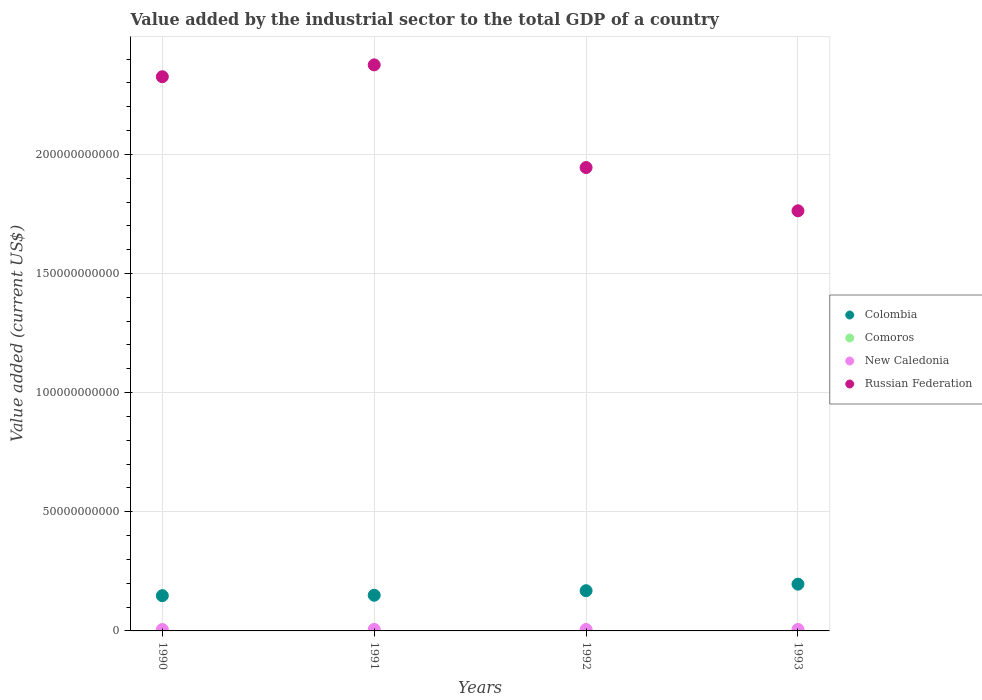What is the value added by the industrial sector to the total GDP in Colombia in 1990?
Make the answer very short. 1.48e+1. Across all years, what is the maximum value added by the industrial sector to the total GDP in New Caledonia?
Your answer should be very brief. 6.39e+08. Across all years, what is the minimum value added by the industrial sector to the total GDP in Russian Federation?
Keep it short and to the point. 1.76e+11. In which year was the value added by the industrial sector to the total GDP in Colombia minimum?
Provide a short and direct response. 1990. What is the total value added by the industrial sector to the total GDP in Russian Federation in the graph?
Your answer should be very brief. 8.41e+11. What is the difference between the value added by the industrial sector to the total GDP in Russian Federation in 1991 and that in 1992?
Your answer should be very brief. 4.31e+1. What is the difference between the value added by the industrial sector to the total GDP in Russian Federation in 1993 and the value added by the industrial sector to the total GDP in New Caledonia in 1990?
Your answer should be compact. 1.76e+11. What is the average value added by the industrial sector to the total GDP in Russian Federation per year?
Offer a very short reply. 2.10e+11. In the year 1991, what is the difference between the value added by the industrial sector to the total GDP in Comoros and value added by the industrial sector to the total GDP in New Caledonia?
Ensure brevity in your answer.  -6.16e+08. What is the ratio of the value added by the industrial sector to the total GDP in Russian Federation in 1990 to that in 1991?
Keep it short and to the point. 0.98. Is the difference between the value added by the industrial sector to the total GDP in Comoros in 1990 and 1992 greater than the difference between the value added by the industrial sector to the total GDP in New Caledonia in 1990 and 1992?
Provide a succinct answer. Yes. What is the difference between the highest and the second highest value added by the industrial sector to the total GDP in New Caledonia?
Ensure brevity in your answer.  1.64e+07. What is the difference between the highest and the lowest value added by the industrial sector to the total GDP in Colombia?
Offer a terse response. 4.83e+09. Is the sum of the value added by the industrial sector to the total GDP in Comoros in 1990 and 1991 greater than the maximum value added by the industrial sector to the total GDP in New Caledonia across all years?
Your response must be concise. No. Is it the case that in every year, the sum of the value added by the industrial sector to the total GDP in Colombia and value added by the industrial sector to the total GDP in New Caledonia  is greater than the sum of value added by the industrial sector to the total GDP in Comoros and value added by the industrial sector to the total GDP in Russian Federation?
Make the answer very short. Yes. Does the value added by the industrial sector to the total GDP in Comoros monotonically increase over the years?
Your answer should be compact. Yes. Is the value added by the industrial sector to the total GDP in Russian Federation strictly less than the value added by the industrial sector to the total GDP in Colombia over the years?
Keep it short and to the point. No. How many years are there in the graph?
Your response must be concise. 4. Does the graph contain any zero values?
Offer a very short reply. No. What is the title of the graph?
Your answer should be compact. Value added by the industrial sector to the total GDP of a country. What is the label or title of the Y-axis?
Offer a very short reply. Value added (current US$). What is the Value added (current US$) of Colombia in 1990?
Your response must be concise. 1.48e+1. What is the Value added (current US$) in Comoros in 1990?
Your answer should be very brief. 2.07e+07. What is the Value added (current US$) of New Caledonia in 1990?
Make the answer very short. 5.90e+08. What is the Value added (current US$) of Russian Federation in 1990?
Offer a very short reply. 2.33e+11. What is the Value added (current US$) of Colombia in 1991?
Ensure brevity in your answer.  1.50e+1. What is the Value added (current US$) in Comoros in 1991?
Your answer should be very brief. 2.31e+07. What is the Value added (current US$) of New Caledonia in 1991?
Offer a very short reply. 6.39e+08. What is the Value added (current US$) of Russian Federation in 1991?
Ensure brevity in your answer.  2.38e+11. What is the Value added (current US$) in Colombia in 1992?
Keep it short and to the point. 1.69e+1. What is the Value added (current US$) in Comoros in 1992?
Your answer should be very brief. 3.05e+07. What is the Value added (current US$) of New Caledonia in 1992?
Offer a terse response. 6.03e+08. What is the Value added (current US$) of Russian Federation in 1992?
Keep it short and to the point. 1.94e+11. What is the Value added (current US$) of Colombia in 1993?
Provide a short and direct response. 1.96e+1. What is the Value added (current US$) of Comoros in 1993?
Offer a terse response. 3.15e+07. What is the Value added (current US$) of New Caledonia in 1993?
Your answer should be compact. 6.23e+08. What is the Value added (current US$) in Russian Federation in 1993?
Your answer should be compact. 1.76e+11. Across all years, what is the maximum Value added (current US$) in Colombia?
Keep it short and to the point. 1.96e+1. Across all years, what is the maximum Value added (current US$) in Comoros?
Give a very brief answer. 3.15e+07. Across all years, what is the maximum Value added (current US$) in New Caledonia?
Offer a very short reply. 6.39e+08. Across all years, what is the maximum Value added (current US$) in Russian Federation?
Make the answer very short. 2.38e+11. Across all years, what is the minimum Value added (current US$) of Colombia?
Make the answer very short. 1.48e+1. Across all years, what is the minimum Value added (current US$) in Comoros?
Ensure brevity in your answer.  2.07e+07. Across all years, what is the minimum Value added (current US$) of New Caledonia?
Give a very brief answer. 5.90e+08. Across all years, what is the minimum Value added (current US$) in Russian Federation?
Keep it short and to the point. 1.76e+11. What is the total Value added (current US$) in Colombia in the graph?
Your answer should be compact. 6.63e+1. What is the total Value added (current US$) in Comoros in the graph?
Provide a succinct answer. 1.06e+08. What is the total Value added (current US$) of New Caledonia in the graph?
Provide a short and direct response. 2.46e+09. What is the total Value added (current US$) in Russian Federation in the graph?
Keep it short and to the point. 8.41e+11. What is the difference between the Value added (current US$) of Colombia in 1990 and that in 1991?
Provide a short and direct response. -1.76e+08. What is the difference between the Value added (current US$) in Comoros in 1990 and that in 1991?
Your response must be concise. -2.46e+06. What is the difference between the Value added (current US$) of New Caledonia in 1990 and that in 1991?
Provide a short and direct response. -4.98e+07. What is the difference between the Value added (current US$) of Russian Federation in 1990 and that in 1991?
Keep it short and to the point. -4.98e+09. What is the difference between the Value added (current US$) in Colombia in 1990 and that in 1992?
Make the answer very short. -2.08e+09. What is the difference between the Value added (current US$) in Comoros in 1990 and that in 1992?
Your answer should be compact. -9.79e+06. What is the difference between the Value added (current US$) in New Caledonia in 1990 and that in 1992?
Offer a terse response. -1.39e+07. What is the difference between the Value added (current US$) in Russian Federation in 1990 and that in 1992?
Give a very brief answer. 3.81e+1. What is the difference between the Value added (current US$) of Colombia in 1990 and that in 1993?
Your answer should be compact. -4.83e+09. What is the difference between the Value added (current US$) of Comoros in 1990 and that in 1993?
Your response must be concise. -1.09e+07. What is the difference between the Value added (current US$) in New Caledonia in 1990 and that in 1993?
Provide a succinct answer. -3.34e+07. What is the difference between the Value added (current US$) of Russian Federation in 1990 and that in 1993?
Provide a short and direct response. 5.63e+1. What is the difference between the Value added (current US$) in Colombia in 1991 and that in 1992?
Provide a succinct answer. -1.91e+09. What is the difference between the Value added (current US$) of Comoros in 1991 and that in 1992?
Give a very brief answer. -7.34e+06. What is the difference between the Value added (current US$) in New Caledonia in 1991 and that in 1992?
Your response must be concise. 3.59e+07. What is the difference between the Value added (current US$) of Russian Federation in 1991 and that in 1992?
Make the answer very short. 4.31e+1. What is the difference between the Value added (current US$) in Colombia in 1991 and that in 1993?
Give a very brief answer. -4.66e+09. What is the difference between the Value added (current US$) in Comoros in 1991 and that in 1993?
Keep it short and to the point. -8.40e+06. What is the difference between the Value added (current US$) of New Caledonia in 1991 and that in 1993?
Keep it short and to the point. 1.64e+07. What is the difference between the Value added (current US$) of Russian Federation in 1991 and that in 1993?
Your answer should be compact. 6.12e+1. What is the difference between the Value added (current US$) of Colombia in 1992 and that in 1993?
Keep it short and to the point. -2.75e+09. What is the difference between the Value added (current US$) in Comoros in 1992 and that in 1993?
Give a very brief answer. -1.06e+06. What is the difference between the Value added (current US$) in New Caledonia in 1992 and that in 1993?
Ensure brevity in your answer.  -1.95e+07. What is the difference between the Value added (current US$) in Russian Federation in 1992 and that in 1993?
Offer a very short reply. 1.82e+1. What is the difference between the Value added (current US$) in Colombia in 1990 and the Value added (current US$) in Comoros in 1991?
Provide a succinct answer. 1.48e+1. What is the difference between the Value added (current US$) of Colombia in 1990 and the Value added (current US$) of New Caledonia in 1991?
Provide a succinct answer. 1.42e+1. What is the difference between the Value added (current US$) of Colombia in 1990 and the Value added (current US$) of Russian Federation in 1991?
Offer a very short reply. -2.23e+11. What is the difference between the Value added (current US$) of Comoros in 1990 and the Value added (current US$) of New Caledonia in 1991?
Ensure brevity in your answer.  -6.19e+08. What is the difference between the Value added (current US$) in Comoros in 1990 and the Value added (current US$) in Russian Federation in 1991?
Ensure brevity in your answer.  -2.38e+11. What is the difference between the Value added (current US$) of New Caledonia in 1990 and the Value added (current US$) of Russian Federation in 1991?
Your answer should be compact. -2.37e+11. What is the difference between the Value added (current US$) of Colombia in 1990 and the Value added (current US$) of Comoros in 1992?
Your response must be concise. 1.48e+1. What is the difference between the Value added (current US$) of Colombia in 1990 and the Value added (current US$) of New Caledonia in 1992?
Keep it short and to the point. 1.42e+1. What is the difference between the Value added (current US$) of Colombia in 1990 and the Value added (current US$) of Russian Federation in 1992?
Offer a terse response. -1.80e+11. What is the difference between the Value added (current US$) of Comoros in 1990 and the Value added (current US$) of New Caledonia in 1992?
Make the answer very short. -5.83e+08. What is the difference between the Value added (current US$) in Comoros in 1990 and the Value added (current US$) in Russian Federation in 1992?
Provide a short and direct response. -1.94e+11. What is the difference between the Value added (current US$) of New Caledonia in 1990 and the Value added (current US$) of Russian Federation in 1992?
Your answer should be compact. -1.94e+11. What is the difference between the Value added (current US$) of Colombia in 1990 and the Value added (current US$) of Comoros in 1993?
Keep it short and to the point. 1.48e+1. What is the difference between the Value added (current US$) in Colombia in 1990 and the Value added (current US$) in New Caledonia in 1993?
Provide a succinct answer. 1.42e+1. What is the difference between the Value added (current US$) of Colombia in 1990 and the Value added (current US$) of Russian Federation in 1993?
Your answer should be very brief. -1.62e+11. What is the difference between the Value added (current US$) in Comoros in 1990 and the Value added (current US$) in New Caledonia in 1993?
Offer a terse response. -6.02e+08. What is the difference between the Value added (current US$) in Comoros in 1990 and the Value added (current US$) in Russian Federation in 1993?
Offer a very short reply. -1.76e+11. What is the difference between the Value added (current US$) of New Caledonia in 1990 and the Value added (current US$) of Russian Federation in 1993?
Ensure brevity in your answer.  -1.76e+11. What is the difference between the Value added (current US$) in Colombia in 1991 and the Value added (current US$) in Comoros in 1992?
Provide a succinct answer. 1.49e+1. What is the difference between the Value added (current US$) of Colombia in 1991 and the Value added (current US$) of New Caledonia in 1992?
Your answer should be very brief. 1.44e+1. What is the difference between the Value added (current US$) of Colombia in 1991 and the Value added (current US$) of Russian Federation in 1992?
Your answer should be very brief. -1.80e+11. What is the difference between the Value added (current US$) of Comoros in 1991 and the Value added (current US$) of New Caledonia in 1992?
Ensure brevity in your answer.  -5.80e+08. What is the difference between the Value added (current US$) in Comoros in 1991 and the Value added (current US$) in Russian Federation in 1992?
Your response must be concise. -1.94e+11. What is the difference between the Value added (current US$) of New Caledonia in 1991 and the Value added (current US$) of Russian Federation in 1992?
Give a very brief answer. -1.94e+11. What is the difference between the Value added (current US$) of Colombia in 1991 and the Value added (current US$) of Comoros in 1993?
Provide a succinct answer. 1.49e+1. What is the difference between the Value added (current US$) in Colombia in 1991 and the Value added (current US$) in New Caledonia in 1993?
Ensure brevity in your answer.  1.43e+1. What is the difference between the Value added (current US$) in Colombia in 1991 and the Value added (current US$) in Russian Federation in 1993?
Give a very brief answer. -1.61e+11. What is the difference between the Value added (current US$) in Comoros in 1991 and the Value added (current US$) in New Caledonia in 1993?
Your response must be concise. -6.00e+08. What is the difference between the Value added (current US$) of Comoros in 1991 and the Value added (current US$) of Russian Federation in 1993?
Make the answer very short. -1.76e+11. What is the difference between the Value added (current US$) of New Caledonia in 1991 and the Value added (current US$) of Russian Federation in 1993?
Offer a very short reply. -1.76e+11. What is the difference between the Value added (current US$) in Colombia in 1992 and the Value added (current US$) in Comoros in 1993?
Provide a succinct answer. 1.68e+1. What is the difference between the Value added (current US$) of Colombia in 1992 and the Value added (current US$) of New Caledonia in 1993?
Your answer should be very brief. 1.63e+1. What is the difference between the Value added (current US$) of Colombia in 1992 and the Value added (current US$) of Russian Federation in 1993?
Provide a succinct answer. -1.59e+11. What is the difference between the Value added (current US$) of Comoros in 1992 and the Value added (current US$) of New Caledonia in 1993?
Your response must be concise. -5.93e+08. What is the difference between the Value added (current US$) in Comoros in 1992 and the Value added (current US$) in Russian Federation in 1993?
Provide a succinct answer. -1.76e+11. What is the difference between the Value added (current US$) of New Caledonia in 1992 and the Value added (current US$) of Russian Federation in 1993?
Your answer should be very brief. -1.76e+11. What is the average Value added (current US$) in Colombia per year?
Give a very brief answer. 1.66e+1. What is the average Value added (current US$) of Comoros per year?
Your answer should be compact. 2.64e+07. What is the average Value added (current US$) in New Caledonia per year?
Offer a terse response. 6.14e+08. What is the average Value added (current US$) in Russian Federation per year?
Your answer should be compact. 2.10e+11. In the year 1990, what is the difference between the Value added (current US$) of Colombia and Value added (current US$) of Comoros?
Your answer should be compact. 1.48e+1. In the year 1990, what is the difference between the Value added (current US$) in Colombia and Value added (current US$) in New Caledonia?
Make the answer very short. 1.42e+1. In the year 1990, what is the difference between the Value added (current US$) of Colombia and Value added (current US$) of Russian Federation?
Keep it short and to the point. -2.18e+11. In the year 1990, what is the difference between the Value added (current US$) in Comoros and Value added (current US$) in New Caledonia?
Ensure brevity in your answer.  -5.69e+08. In the year 1990, what is the difference between the Value added (current US$) in Comoros and Value added (current US$) in Russian Federation?
Offer a very short reply. -2.33e+11. In the year 1990, what is the difference between the Value added (current US$) in New Caledonia and Value added (current US$) in Russian Federation?
Ensure brevity in your answer.  -2.32e+11. In the year 1991, what is the difference between the Value added (current US$) in Colombia and Value added (current US$) in Comoros?
Give a very brief answer. 1.49e+1. In the year 1991, what is the difference between the Value added (current US$) in Colombia and Value added (current US$) in New Caledonia?
Your response must be concise. 1.43e+1. In the year 1991, what is the difference between the Value added (current US$) of Colombia and Value added (current US$) of Russian Federation?
Your answer should be very brief. -2.23e+11. In the year 1991, what is the difference between the Value added (current US$) of Comoros and Value added (current US$) of New Caledonia?
Your answer should be compact. -6.16e+08. In the year 1991, what is the difference between the Value added (current US$) of Comoros and Value added (current US$) of Russian Federation?
Offer a very short reply. -2.38e+11. In the year 1991, what is the difference between the Value added (current US$) in New Caledonia and Value added (current US$) in Russian Federation?
Ensure brevity in your answer.  -2.37e+11. In the year 1992, what is the difference between the Value added (current US$) of Colombia and Value added (current US$) of Comoros?
Ensure brevity in your answer.  1.68e+1. In the year 1992, what is the difference between the Value added (current US$) of Colombia and Value added (current US$) of New Caledonia?
Your answer should be very brief. 1.63e+1. In the year 1992, what is the difference between the Value added (current US$) of Colombia and Value added (current US$) of Russian Federation?
Make the answer very short. -1.78e+11. In the year 1992, what is the difference between the Value added (current US$) in Comoros and Value added (current US$) in New Caledonia?
Keep it short and to the point. -5.73e+08. In the year 1992, what is the difference between the Value added (current US$) of Comoros and Value added (current US$) of Russian Federation?
Ensure brevity in your answer.  -1.94e+11. In the year 1992, what is the difference between the Value added (current US$) of New Caledonia and Value added (current US$) of Russian Federation?
Offer a terse response. -1.94e+11. In the year 1993, what is the difference between the Value added (current US$) of Colombia and Value added (current US$) of Comoros?
Your answer should be very brief. 1.96e+1. In the year 1993, what is the difference between the Value added (current US$) in Colombia and Value added (current US$) in New Caledonia?
Offer a terse response. 1.90e+1. In the year 1993, what is the difference between the Value added (current US$) in Colombia and Value added (current US$) in Russian Federation?
Make the answer very short. -1.57e+11. In the year 1993, what is the difference between the Value added (current US$) in Comoros and Value added (current US$) in New Caledonia?
Provide a short and direct response. -5.92e+08. In the year 1993, what is the difference between the Value added (current US$) in Comoros and Value added (current US$) in Russian Federation?
Your answer should be compact. -1.76e+11. In the year 1993, what is the difference between the Value added (current US$) in New Caledonia and Value added (current US$) in Russian Federation?
Provide a succinct answer. -1.76e+11. What is the ratio of the Value added (current US$) in Colombia in 1990 to that in 1991?
Your response must be concise. 0.99. What is the ratio of the Value added (current US$) of Comoros in 1990 to that in 1991?
Keep it short and to the point. 0.89. What is the ratio of the Value added (current US$) in New Caledonia in 1990 to that in 1991?
Provide a short and direct response. 0.92. What is the ratio of the Value added (current US$) of Colombia in 1990 to that in 1992?
Give a very brief answer. 0.88. What is the ratio of the Value added (current US$) in Comoros in 1990 to that in 1992?
Keep it short and to the point. 0.68. What is the ratio of the Value added (current US$) in Russian Federation in 1990 to that in 1992?
Provide a succinct answer. 1.2. What is the ratio of the Value added (current US$) in Colombia in 1990 to that in 1993?
Your answer should be very brief. 0.75. What is the ratio of the Value added (current US$) in Comoros in 1990 to that in 1993?
Ensure brevity in your answer.  0.66. What is the ratio of the Value added (current US$) of New Caledonia in 1990 to that in 1993?
Keep it short and to the point. 0.95. What is the ratio of the Value added (current US$) in Russian Federation in 1990 to that in 1993?
Provide a short and direct response. 1.32. What is the ratio of the Value added (current US$) of Colombia in 1991 to that in 1992?
Your answer should be compact. 0.89. What is the ratio of the Value added (current US$) of Comoros in 1991 to that in 1992?
Offer a terse response. 0.76. What is the ratio of the Value added (current US$) in New Caledonia in 1991 to that in 1992?
Your answer should be very brief. 1.06. What is the ratio of the Value added (current US$) in Russian Federation in 1991 to that in 1992?
Your response must be concise. 1.22. What is the ratio of the Value added (current US$) in Colombia in 1991 to that in 1993?
Your answer should be compact. 0.76. What is the ratio of the Value added (current US$) of Comoros in 1991 to that in 1993?
Offer a terse response. 0.73. What is the ratio of the Value added (current US$) of New Caledonia in 1991 to that in 1993?
Offer a terse response. 1.03. What is the ratio of the Value added (current US$) in Russian Federation in 1991 to that in 1993?
Offer a very short reply. 1.35. What is the ratio of the Value added (current US$) of Colombia in 1992 to that in 1993?
Offer a very short reply. 0.86. What is the ratio of the Value added (current US$) in Comoros in 1992 to that in 1993?
Offer a very short reply. 0.97. What is the ratio of the Value added (current US$) in New Caledonia in 1992 to that in 1993?
Your response must be concise. 0.97. What is the ratio of the Value added (current US$) in Russian Federation in 1992 to that in 1993?
Your response must be concise. 1.1. What is the difference between the highest and the second highest Value added (current US$) in Colombia?
Your answer should be compact. 2.75e+09. What is the difference between the highest and the second highest Value added (current US$) in Comoros?
Make the answer very short. 1.06e+06. What is the difference between the highest and the second highest Value added (current US$) of New Caledonia?
Ensure brevity in your answer.  1.64e+07. What is the difference between the highest and the second highest Value added (current US$) of Russian Federation?
Provide a short and direct response. 4.98e+09. What is the difference between the highest and the lowest Value added (current US$) in Colombia?
Provide a short and direct response. 4.83e+09. What is the difference between the highest and the lowest Value added (current US$) of Comoros?
Provide a short and direct response. 1.09e+07. What is the difference between the highest and the lowest Value added (current US$) of New Caledonia?
Your answer should be very brief. 4.98e+07. What is the difference between the highest and the lowest Value added (current US$) in Russian Federation?
Your response must be concise. 6.12e+1. 